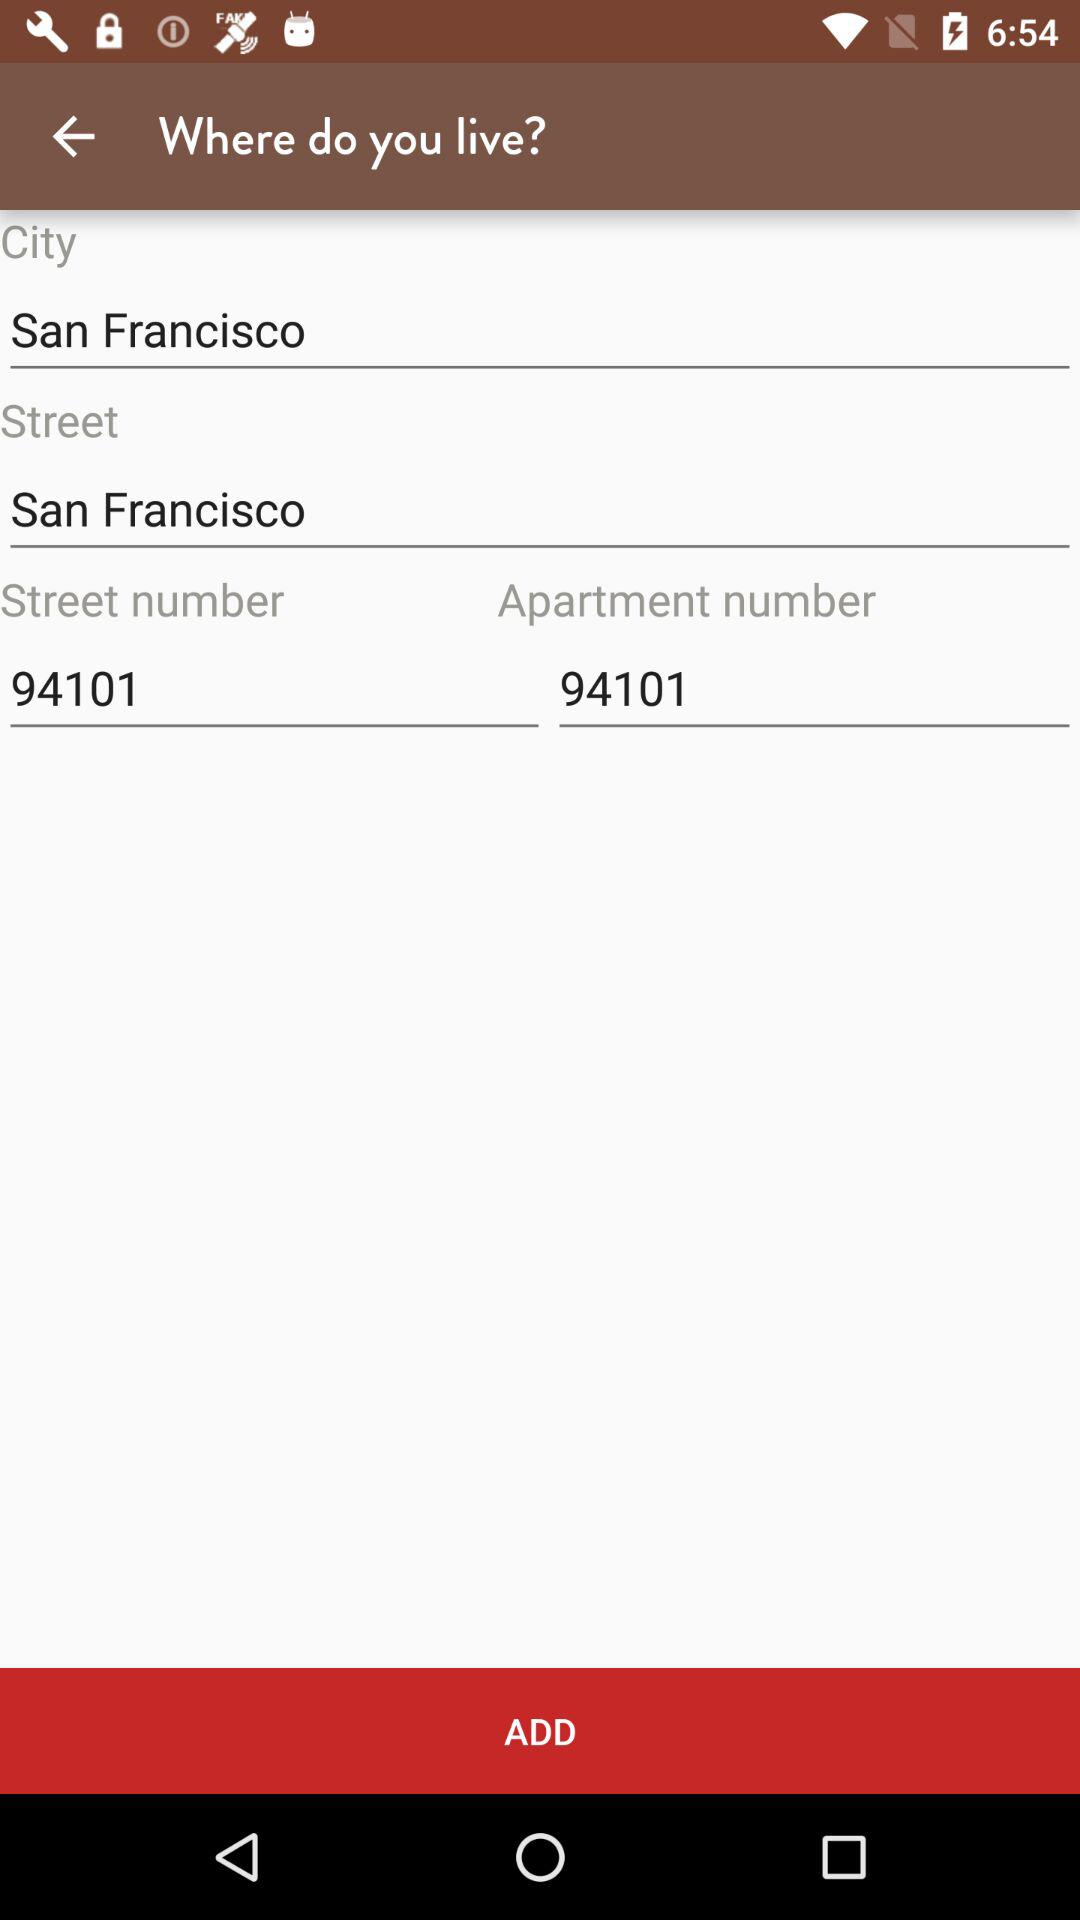What is the apartment number? The apartment number is 94101. 